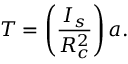<formula> <loc_0><loc_0><loc_500><loc_500>T = \left ( \frac { I _ { s } } { R _ { c } ^ { 2 } } \right ) a .</formula> 